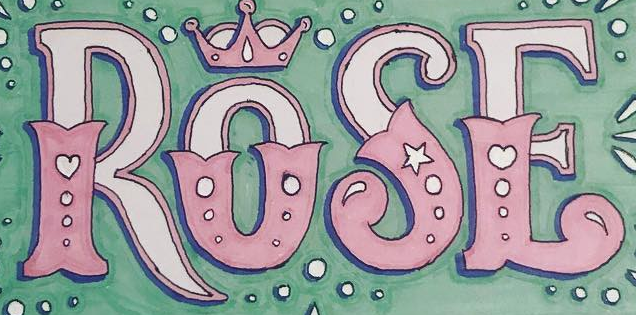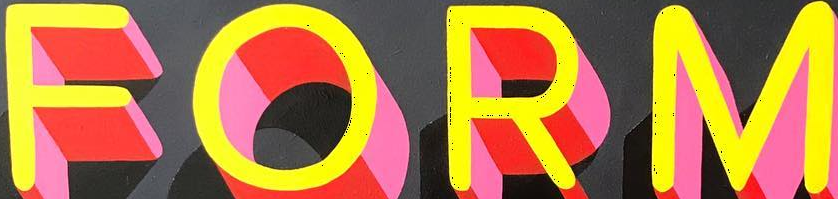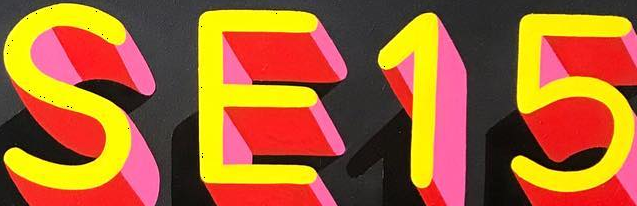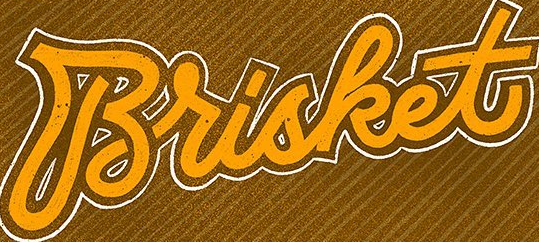Read the text from these images in sequence, separated by a semicolon. ROSE; FORM; SE15; Brisket 